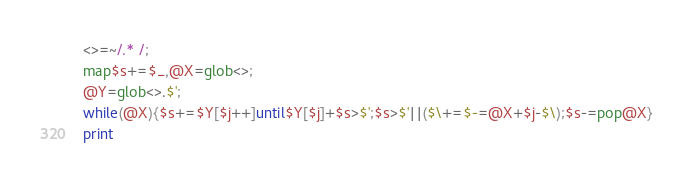Convert code to text. <code><loc_0><loc_0><loc_500><loc_500><_Perl_><>=~/.* /;
map$s+=$_,@X=glob<>;
@Y=glob<>.$';
while(@X){$s+=$Y[$j++]until$Y[$j]+$s>$';$s>$'||($\+=$-=@X+$j-$\);$s-=pop@X}
print</code> 